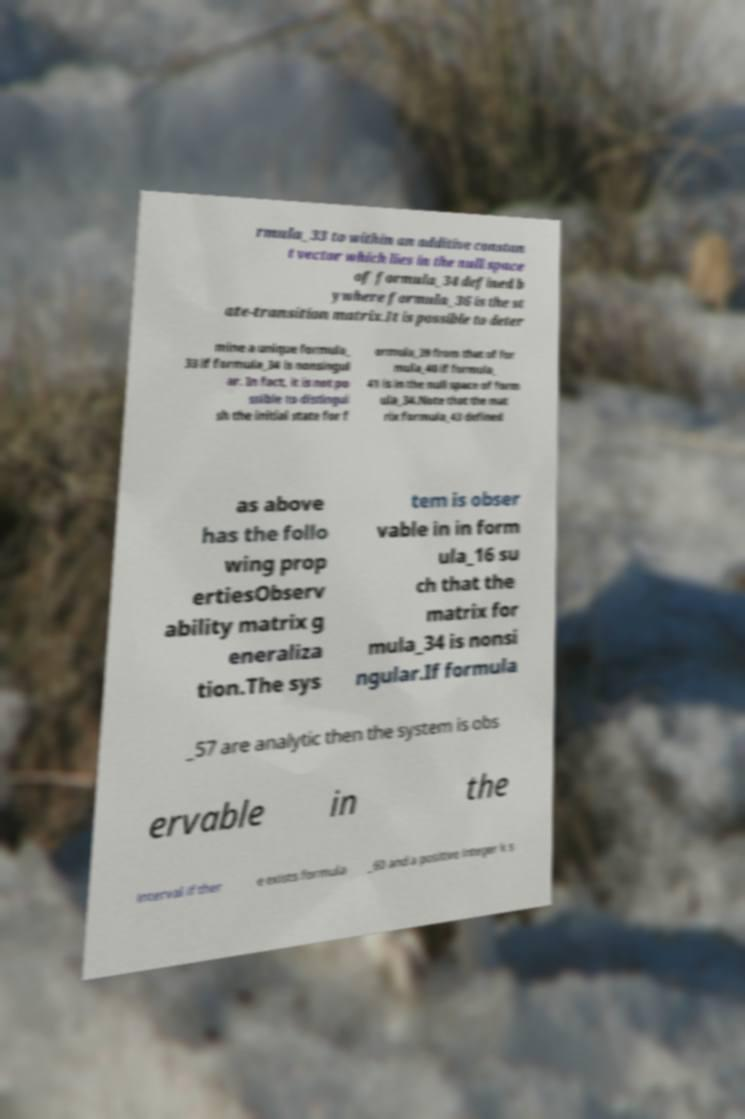I need the written content from this picture converted into text. Can you do that? rmula_33 to within an additive constan t vector which lies in the null space of formula_34 defined b ywhere formula_36 is the st ate-transition matrix.It is possible to deter mine a unique formula_ 33 if formula_34 is nonsingul ar. In fact, it is not po ssible to distingui sh the initial state for f ormula_39 from that of for mula_40 if formula_ 41 is in the null space of form ula_34.Note that the mat rix formula_43 defined as above has the follo wing prop ertiesObserv ability matrix g eneraliza tion.The sys tem is obser vable in in form ula_16 su ch that the matrix for mula_34 is nonsi ngular.If formula _57 are analytic then the system is obs ervable in the interval if ther e exists formula _60 and a positive integer k s 